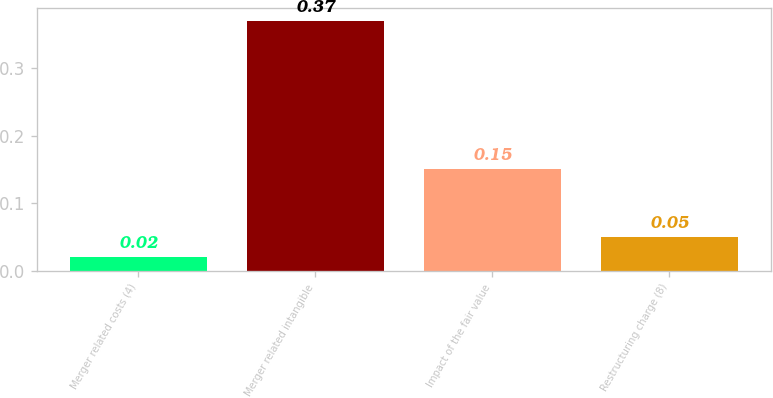<chart> <loc_0><loc_0><loc_500><loc_500><bar_chart><fcel>Merger related costs (4)<fcel>Merger related intangible<fcel>Impact of the fair value<fcel>Restructuring charge (8)<nl><fcel>0.02<fcel>0.37<fcel>0.15<fcel>0.05<nl></chart> 